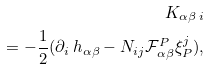<formula> <loc_0><loc_0><loc_500><loc_500>K _ { \alpha \beta \, i } \\ = - \frac { 1 } { 2 } ( \partial _ { i } \, h _ { \alpha \beta } - N _ { i j } \mathcal { F } _ { \alpha \beta } ^ { P } \xi ^ { j } _ { P } ) ,</formula> 